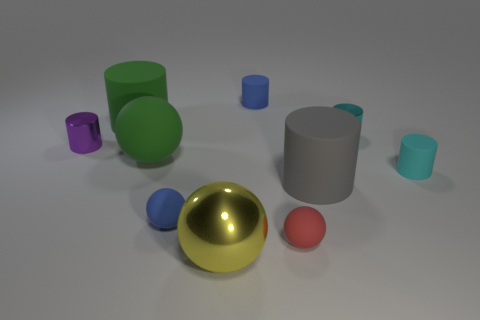Subtract all blue spheres. How many spheres are left? 3 Subtract all yellow balls. How many balls are left? 3 Subtract all blue balls. Subtract all red blocks. How many balls are left? 3 Subtract all spheres. How many objects are left? 6 Subtract all green rubber cylinders. Subtract all small cylinders. How many objects are left? 5 Add 5 large gray rubber objects. How many large gray rubber objects are left? 6 Add 8 small cyan matte cubes. How many small cyan matte cubes exist? 8 Subtract 1 cyan cylinders. How many objects are left? 9 